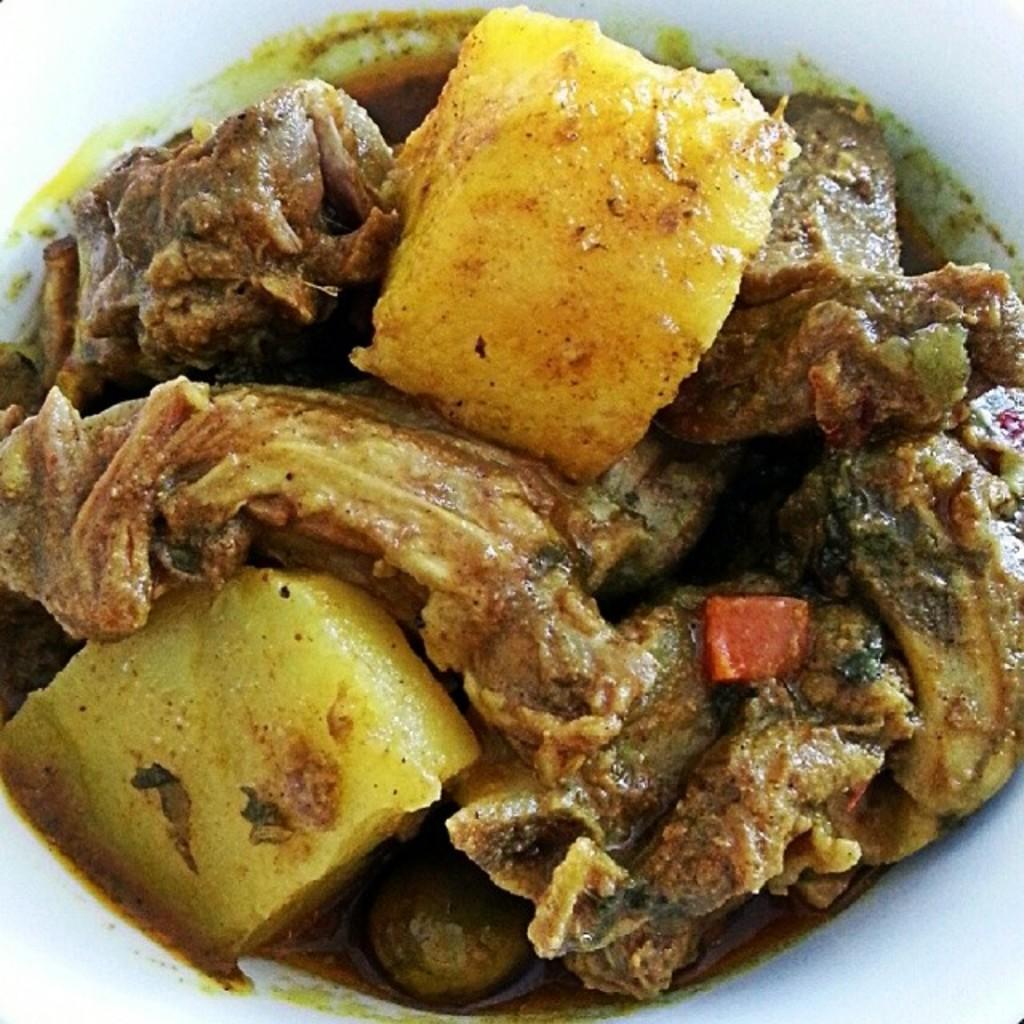What can be seen in the image? There is food in the image. What is the price of the bat in the image? There is no bat present in the image, so it is not possible to determine its price. 